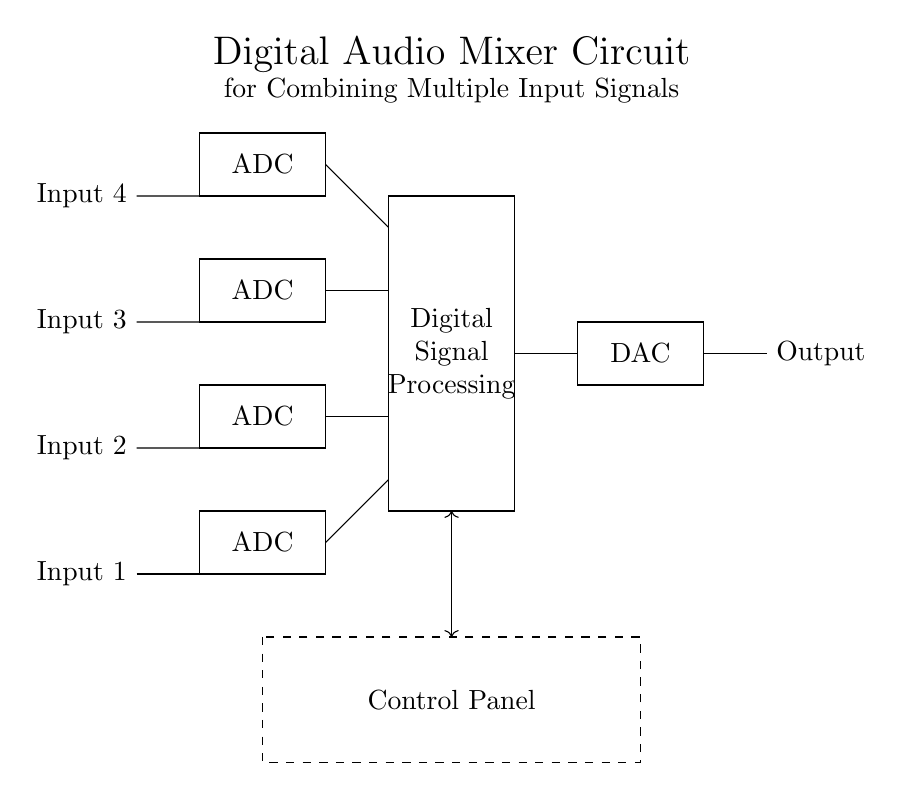What are the input signals in this circuit? The input signals are labeled as Input 1, Input 2, Input 3, and Input 4 on the left side of the diagram. Each goes into an ADC for conversion.
Answer: Input 1, Input 2, Input 3, Input 4 How many ADCs are present in this circuit? Each input signal connects to its own ADC. Since there are four input signals represented in the circuit, there are four corresponding ADCs.
Answer: Four What does DSP stand for in this circuit? DSP is an abbreviation commonly used in audio circuits, which stands for Digital Signal Processing, and it is shown as a rectangular box in the middle of the circuit.
Answer: Digital Signal Processing Where do the signals go after the ADCs? After passing through the ADCs, the digital signals are connected to the Digital Signal Processing block, which processes the signals before they are converted back to analog.
Answer: To Digital Signal Processing What is the output of the circuit? The output of the circuit is given explicitly on the right side of the diagram, indicating that the processed signals are sent out as an Output.
Answer: Output What is the purpose of the DAC in the circuit? The DAC, which stands for Digital-to-Analog Converter, serves to convert the processed digital signals from the DSP back into analog signals for output, completing the audio mixing process.
Answer: Convert digital to analog What component allows user control of the signals? The dashed rectangle labeled as the Control Panel encapsulates controls for adjusting the mixer settings and managing the inputs and outputs of the circuit.
Answer: Control Panel 